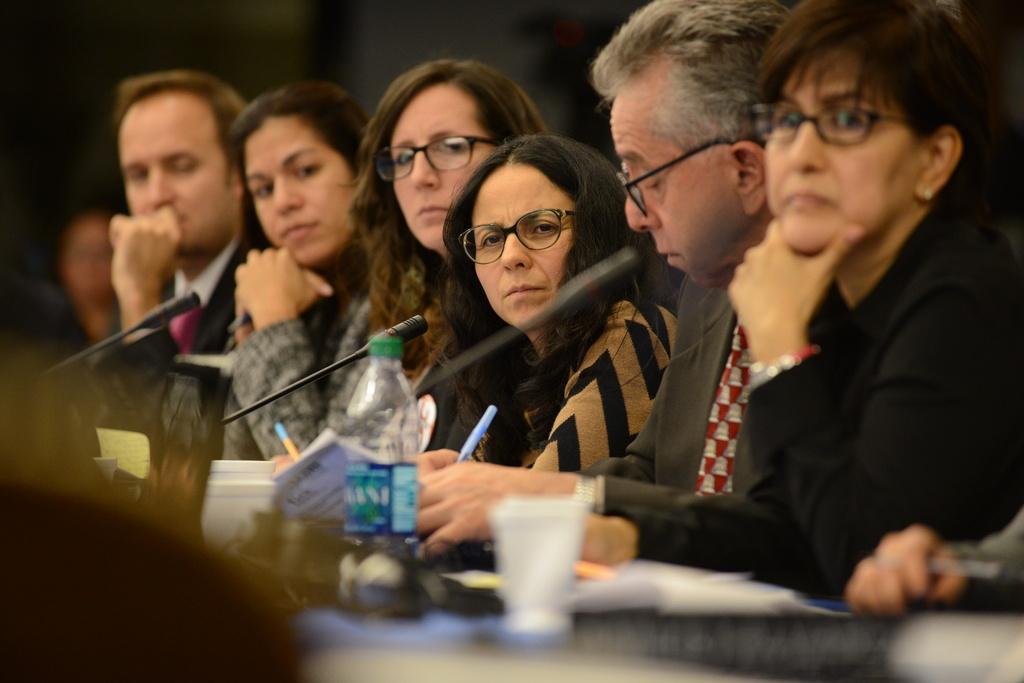Describe this image in one or two sentences. In this picture I can see so many people in front of the table, on which there are some books, mike's, bottle and some things placed. 